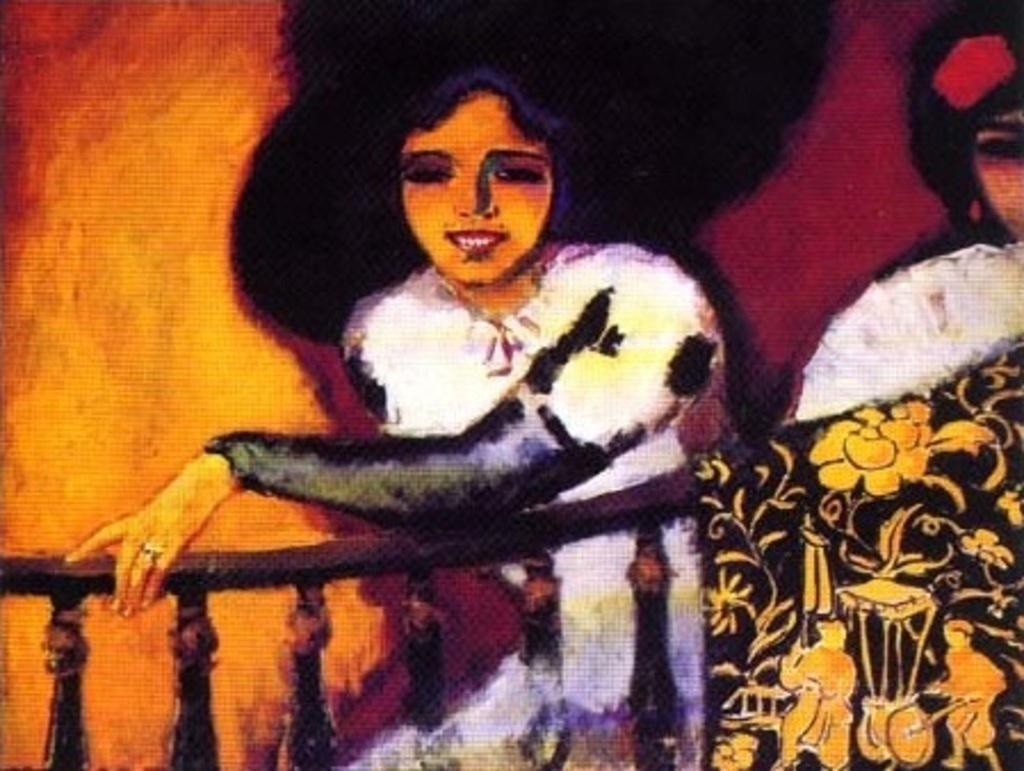What is the nature of the image? The image appears to be edited. What is the main subject of the painting within the image? There is a painting of two persons in the image. Are there any other paintings visible in the image? Yes, there are paintings of other objects in the image. What type of cemetery can be seen in the image? There is no cemetery present in the image. How is the hose being used in the image? There is no hose present in the image. 